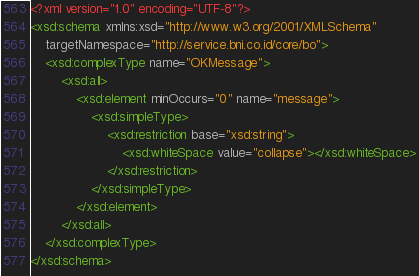Convert code to text. <code><loc_0><loc_0><loc_500><loc_500><_XML_><?xml version="1.0" encoding="UTF-8"?>
<xsd:schema xmlns:xsd="http://www.w3.org/2001/XMLSchema"
	targetNamespace="http://service.bni.co.id/core/bo">
	<xsd:complexType name="OKMessage">
		<xsd:all>
			<xsd:element minOccurs="0" name="message">
				<xsd:simpleType>
					<xsd:restriction base="xsd:string">
						<xsd:whiteSpace value="collapse"></xsd:whiteSpace>
					</xsd:restriction>
				</xsd:simpleType>
			</xsd:element>
		</xsd:all>
	</xsd:complexType>
</xsd:schema>
</code> 